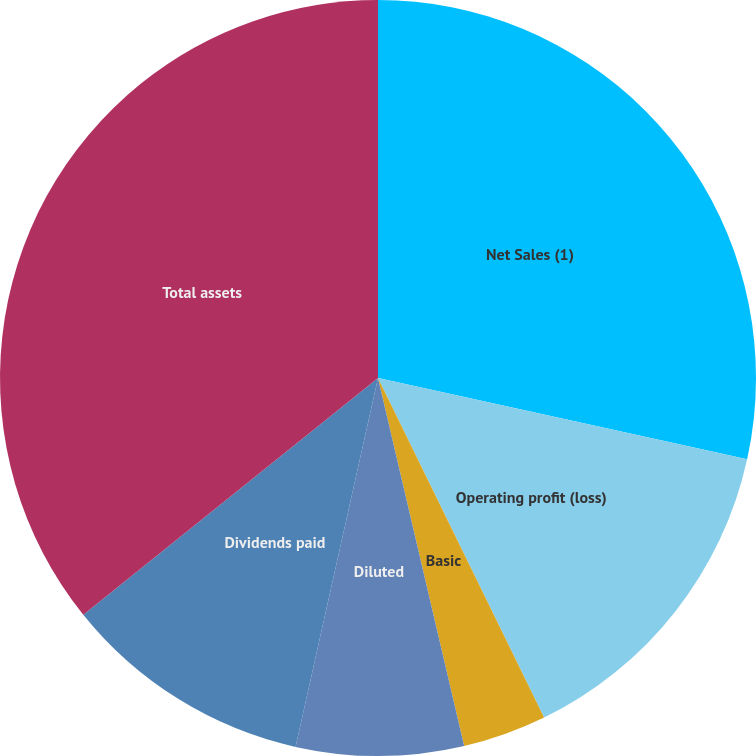<chart> <loc_0><loc_0><loc_500><loc_500><pie_chart><fcel>Net Sales (1)<fcel>Operating profit (loss)<fcel>Basic<fcel>Diluted<fcel>Dividends declared<fcel>Dividends paid<fcel>Total assets<nl><fcel>28.45%<fcel>14.31%<fcel>3.58%<fcel>7.16%<fcel>0.0%<fcel>10.73%<fcel>35.77%<nl></chart> 